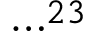Convert formula to latex. <formula><loc_0><loc_0><loc_500><loc_500>\cdots ^ { 2 3 }</formula> 